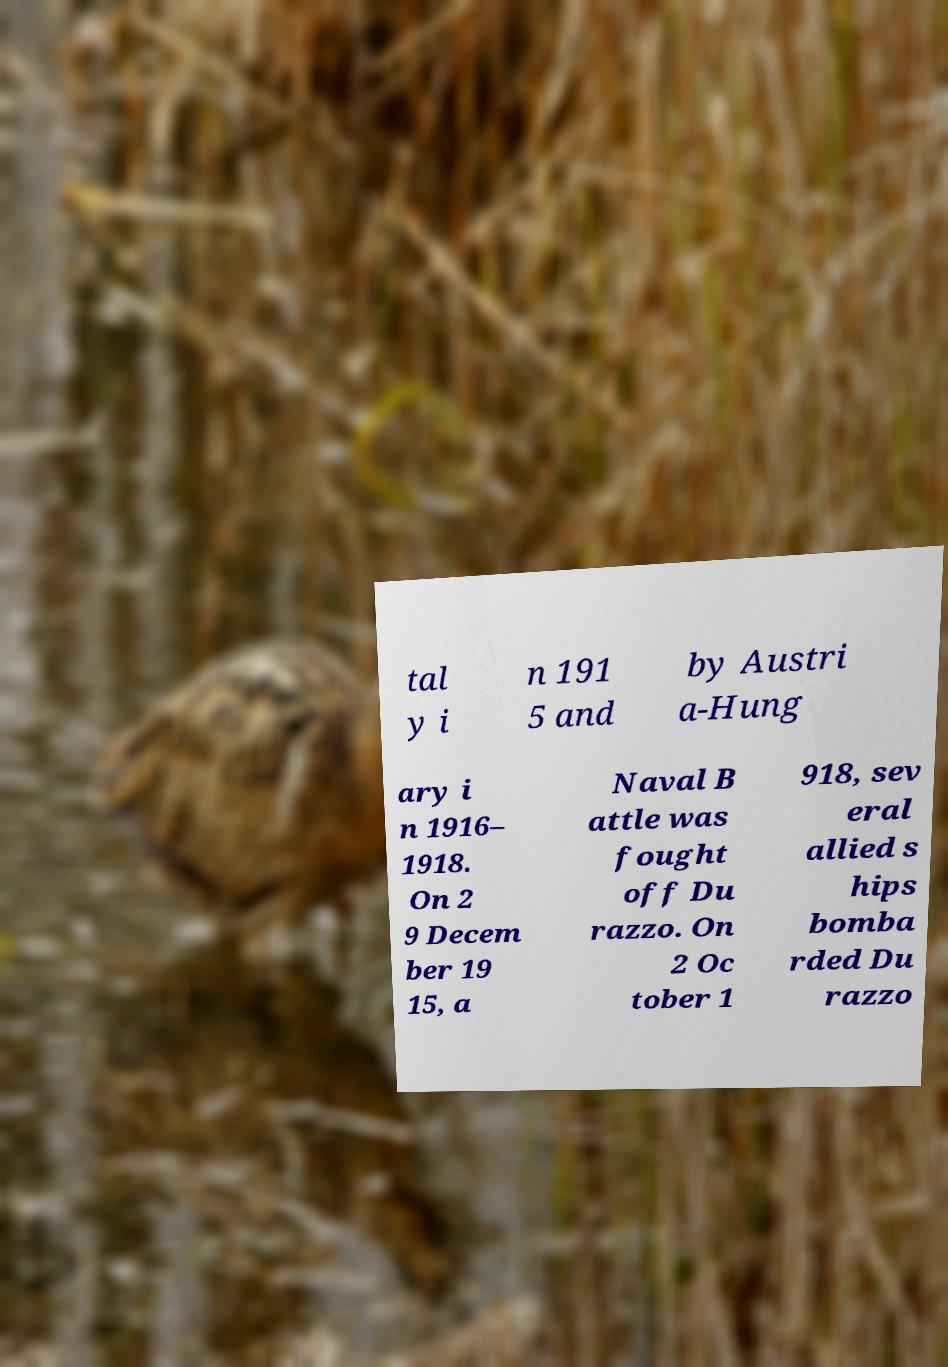What messages or text are displayed in this image? I need them in a readable, typed format. tal y i n 191 5 and by Austri a-Hung ary i n 1916– 1918. On 2 9 Decem ber 19 15, a Naval B attle was fought off Du razzo. On 2 Oc tober 1 918, sev eral allied s hips bomba rded Du razzo 